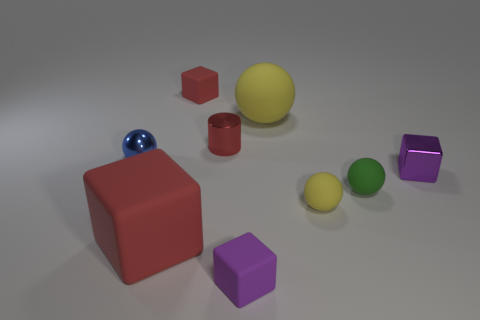Add 1 small green spheres. How many objects exist? 10 Subtract all cylinders. How many objects are left? 8 Add 5 tiny purple cubes. How many tiny purple cubes are left? 7 Add 5 red matte objects. How many red matte objects exist? 7 Subtract 1 green balls. How many objects are left? 8 Subtract all purple matte blocks. Subtract all tiny blue shiny spheres. How many objects are left? 7 